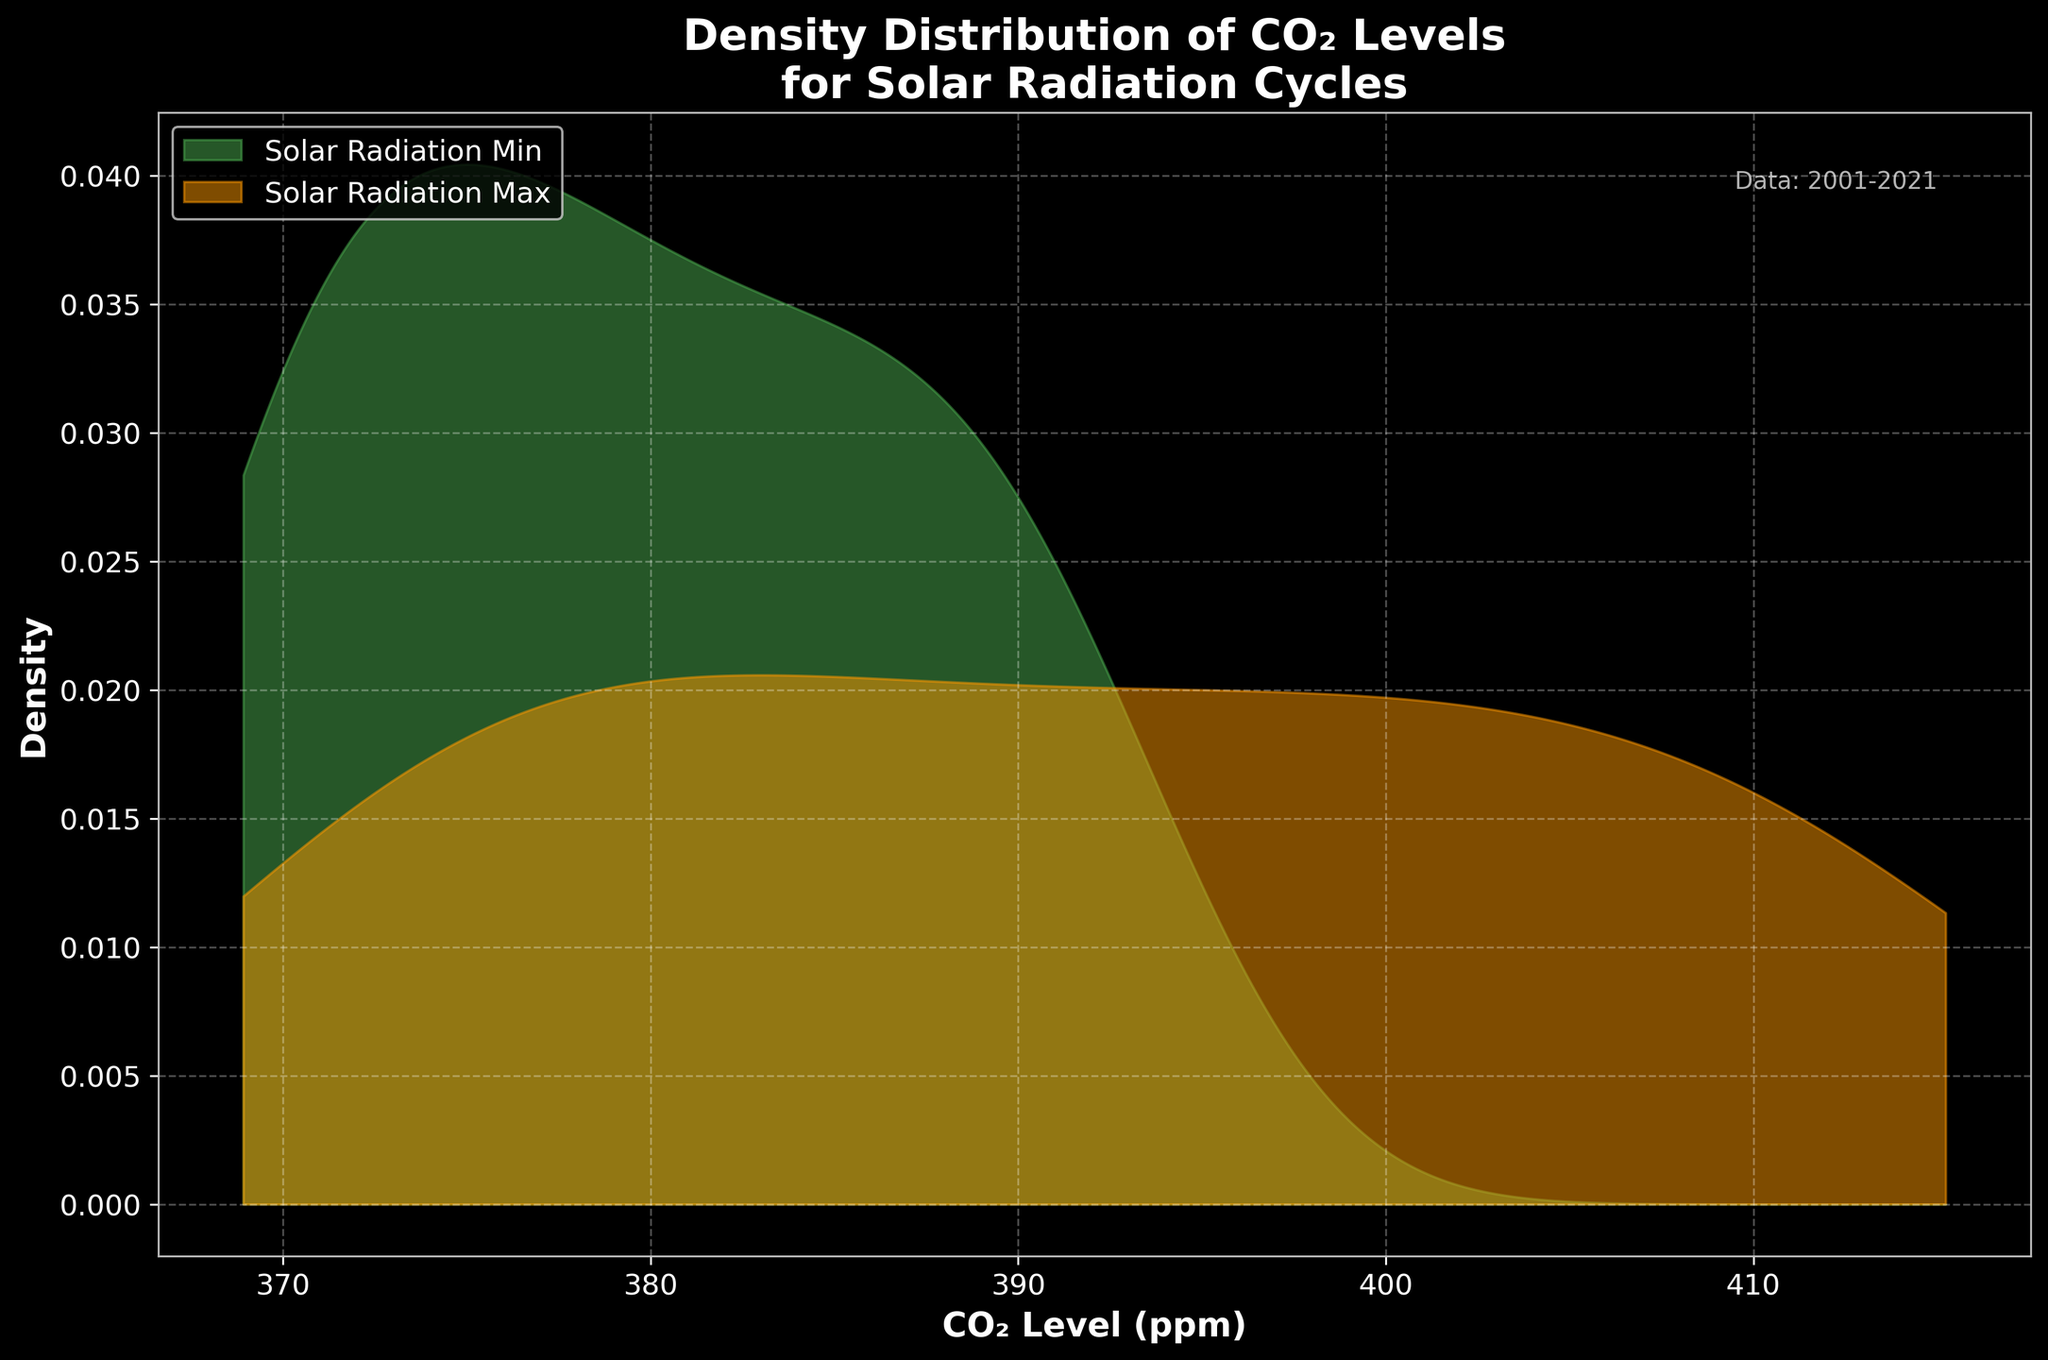What is the title of the plot? Look at the top of the figure where the title is generally placed.
Answer: Density Distribution of CO₂ Levels for Solar Radiation Cycles What are the colors representing Solar Radiation Min and Max cycles in the plot? Identify the two different shaded regions in the plot and refer to the legend. The green shade corresponds to Solar Radiation Min, and the orange shade corresponds to Solar Radiation Max.
Answer: Green for Min, Orange for Max What are the x-axis and y-axis labels in the plot? Examine the labels on the horizontal and vertical axes.
Answer: CO₂ Level (ppm) and Density Is there a clear distinction between CO₂ levels during Solar Radiation Min and Max cycles? Compare the density distributions for the Min and Max cycles. The peaks and spread can provide insights into the differences. The Solar Radiation Max cycle shows higher CO₂ levels than the Min cycle.
Answer: Yes Which solar radiation cycle has a peak CO₂ density around 370-375 ppm? Look at the x-axis range from 370 to 375 ppm and identify which density curve peaks in this range. The Solar Radiation Min cycle has its peak around this range.
Answer: Solar Radiation Min Does the Solar Radiation Max cycle show a higher CO₂ level density peak than the Solar Radiation Min cycle? Compare the peaks of both density distributions. Identify if the density peak is higher for the Max cycle. The Solar Radiation Max cycle shows higher CO₂ levels overall.
Answer: Yes Approximately what is the range of CO₂ levels for the Solar Radiation Max cycle density? Identify the spread of the density curve for the Solar Radiation Max cycle on the x-axis.
Answer: 370 to 415 ppm During which periods did CO₂ levels show a broad distribution, and how can this be inferred from the plot? Compare the spread of both density curves to determine which one has a broader range. The Solar Radiation Max cycle shows a broader distribution, indicating more variability in CO₂ levels during these periods.
Answer: During Solar Radiation Max cycles Is there any overlap between the CO₂ level densities of the two solar radiation cycles? Examine the plot to see if the density curves for Min and Max overlap at any CO₂ level range. Yes, the densities overlap, particularly between 375 and 390 ppm.
Answer: Yes What annotation is included in the figure to specify the data range? Look for any text annotations within or near the plot area that provide additional information. The annotation "Data: 2001-2021" is visible in the upper right part of the plot.
Answer: Data: 2001-2021 